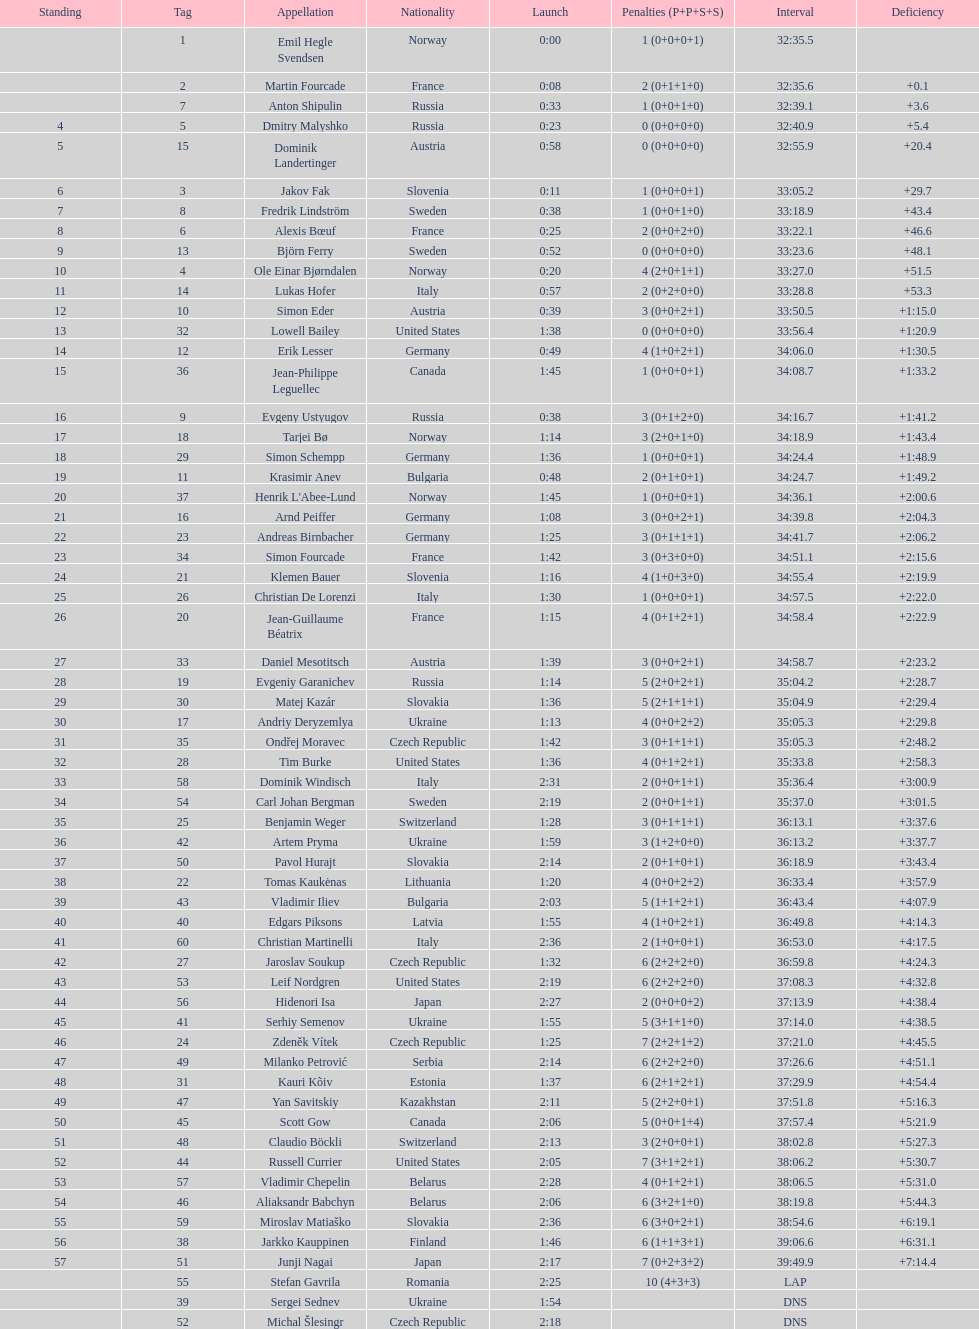How many united states competitors did not win medals? 4. 